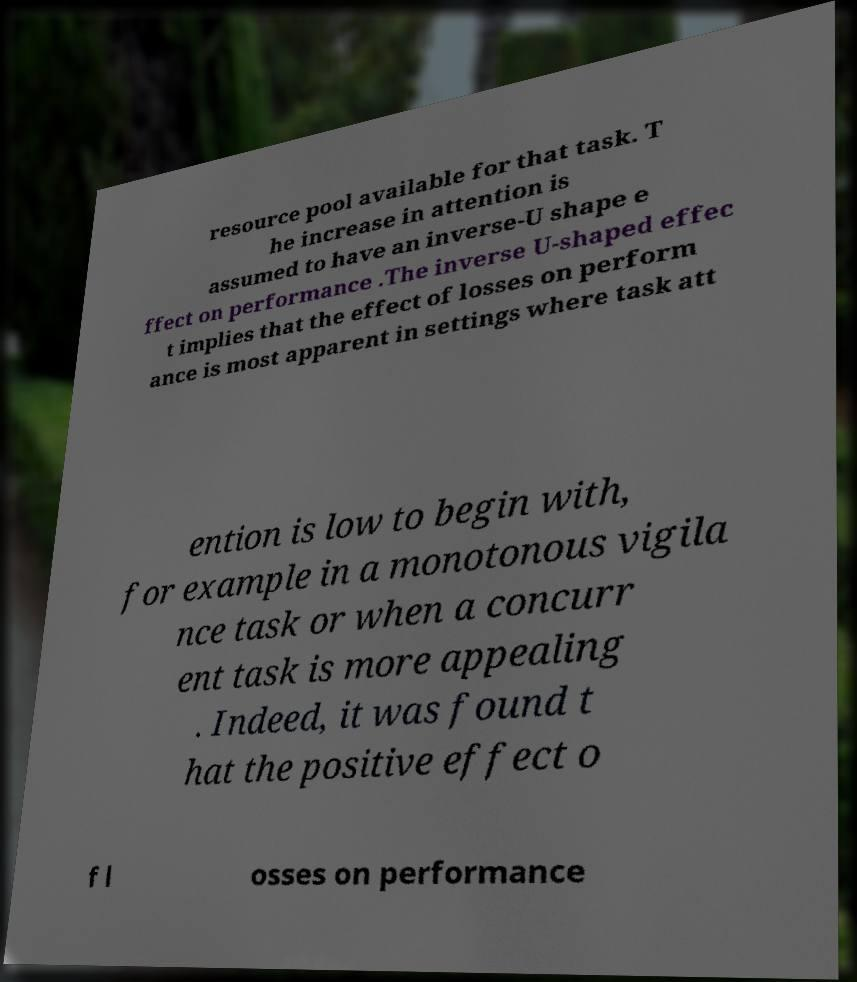Could you assist in decoding the text presented in this image and type it out clearly? resource pool available for that task. T he increase in attention is assumed to have an inverse-U shape e ffect on performance .The inverse U-shaped effec t implies that the effect of losses on perform ance is most apparent in settings where task att ention is low to begin with, for example in a monotonous vigila nce task or when a concurr ent task is more appealing . Indeed, it was found t hat the positive effect o f l osses on performance 